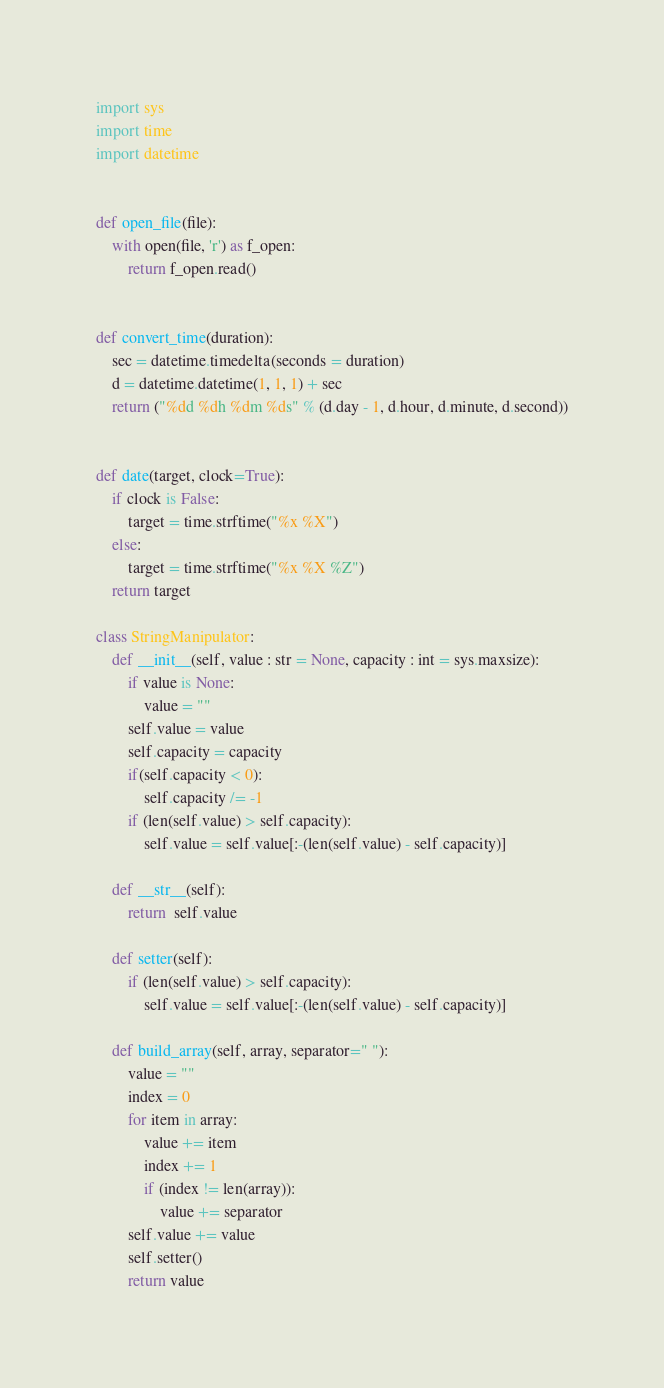Convert code to text. <code><loc_0><loc_0><loc_500><loc_500><_Python_>import sys
import time
import datetime


def open_file(file):
    with open(file, 'r') as f_open:
        return f_open.read()


def convert_time(duration):
    sec = datetime.timedelta(seconds = duration)
    d = datetime.datetime(1, 1, 1) + sec
    return ("%dd %dh %dm %ds" % (d.day - 1, d.hour, d.minute, d.second))


def date(target, clock=True):
    if clock is False:
        target = time.strftime("%x %X")
    else:
        target = time.strftime("%x %X %Z")
    return target

class StringManipulator:
    def __init__(self, value : str = None, capacity : int = sys.maxsize):
        if value is None:
            value = ""
        self.value = value
        self.capacity = capacity
        if(self.capacity < 0):
            self.capacity /= -1
        if (len(self.value) > self.capacity):
            self.value = self.value[:-(len(self.value) - self.capacity)]

    def __str__(self):
        return  self.value

    def setter(self):
        if (len(self.value) > self.capacity):
            self.value = self.value[:-(len(self.value) - self.capacity)]

    def build_array(self, array, separator=" "):
        value = ""
        index = 0
        for item in array:
            value += item
            index += 1
            if (index != len(array)):
                value += separator
        self.value += value
        self.setter()
        return value</code> 